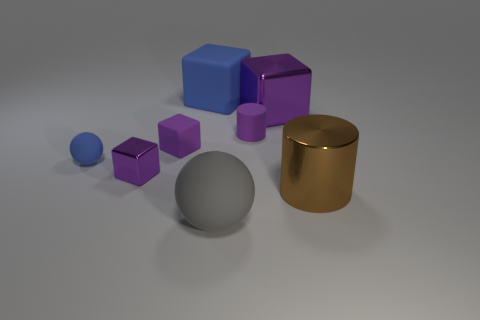What materials do the objects in the image seem to be made of? The objects in the image appear to be rendered with different materials. The shiny gold cylinder looks like it's made of a polished metal, possibly brass or gold in color. The purple objects have a matte finish, typical of a solid plastic or painted wood. The large grey sphere in the middle appears to have a satin finish that could resemble a smooth stone or ceramic. 